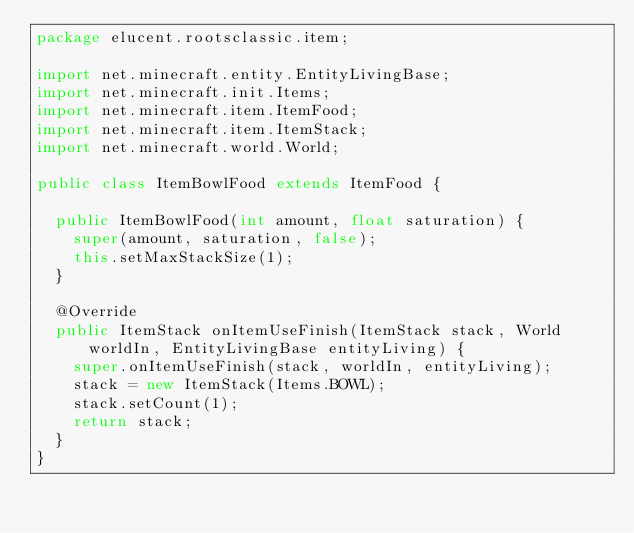<code> <loc_0><loc_0><loc_500><loc_500><_Java_>package elucent.rootsclassic.item;

import net.minecraft.entity.EntityLivingBase;
import net.minecraft.init.Items;
import net.minecraft.item.ItemFood;
import net.minecraft.item.ItemStack;
import net.minecraft.world.World;

public class ItemBowlFood extends ItemFood {

  public ItemBowlFood(int amount, float saturation) {
    super(amount, saturation, false);
    this.setMaxStackSize(1);
  }

  @Override
  public ItemStack onItemUseFinish(ItemStack stack, World worldIn, EntityLivingBase entityLiving) {
    super.onItemUseFinish(stack, worldIn, entityLiving);
    stack = new ItemStack(Items.BOWL);
    stack.setCount(1);
    return stack;
  }
}
</code> 